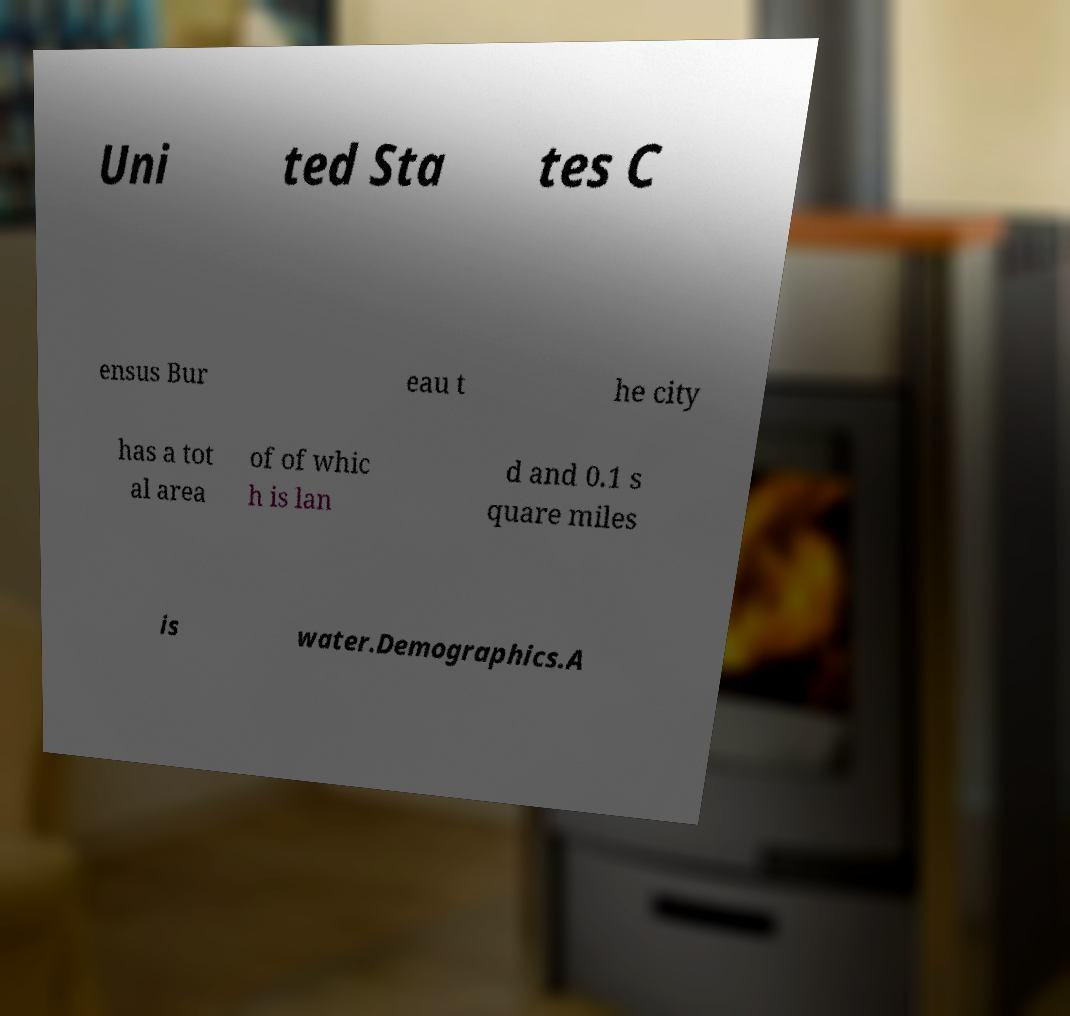Can you accurately transcribe the text from the provided image for me? Uni ted Sta tes C ensus Bur eau t he city has a tot al area of of whic h is lan d and 0.1 s quare miles is water.Demographics.A 